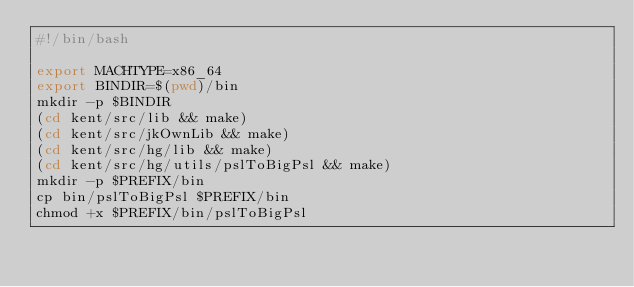Convert code to text. <code><loc_0><loc_0><loc_500><loc_500><_Bash_>#!/bin/bash

export MACHTYPE=x86_64
export BINDIR=$(pwd)/bin
mkdir -p $BINDIR
(cd kent/src/lib && make)
(cd kent/src/jkOwnLib && make)
(cd kent/src/hg/lib && make)
(cd kent/src/hg/utils/pslToBigPsl && make)
mkdir -p $PREFIX/bin
cp bin/pslToBigPsl $PREFIX/bin
chmod +x $PREFIX/bin/pslToBigPsl
</code> 